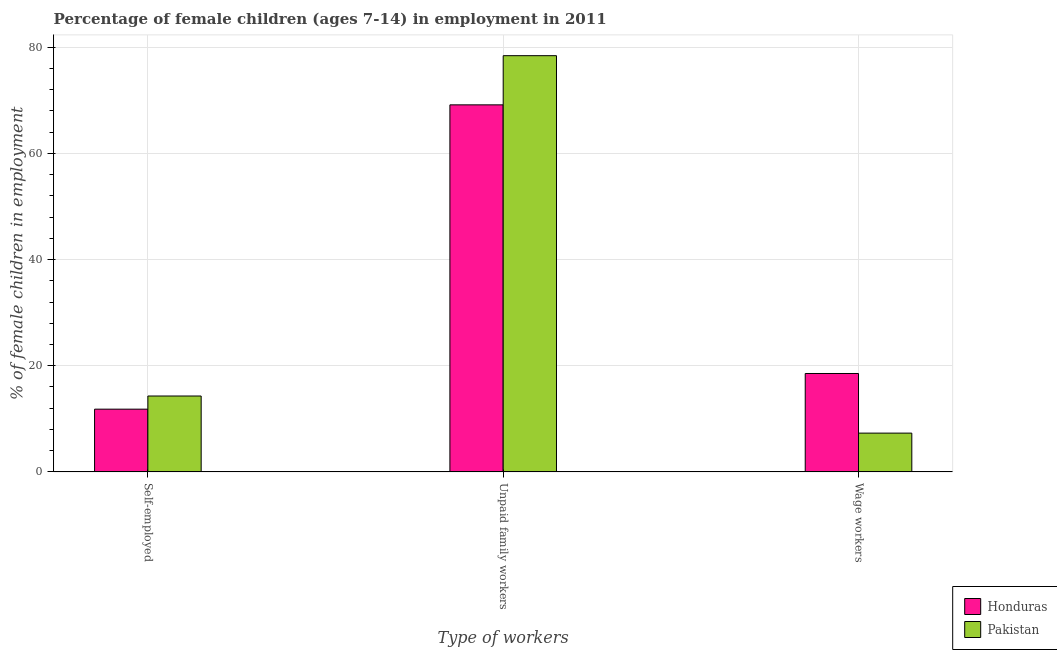How many bars are there on the 3rd tick from the right?
Offer a terse response. 2. What is the label of the 3rd group of bars from the left?
Give a very brief answer. Wage workers. What is the percentage of self employed children in Honduras?
Give a very brief answer. 11.82. Across all countries, what is the minimum percentage of children employed as wage workers?
Offer a terse response. 7.31. In which country was the percentage of children employed as wage workers maximum?
Your answer should be very brief. Honduras. In which country was the percentage of children employed as wage workers minimum?
Provide a short and direct response. Pakistan. What is the total percentage of children employed as unpaid family workers in the graph?
Ensure brevity in your answer.  147.52. What is the difference between the percentage of children employed as unpaid family workers in Honduras and that in Pakistan?
Ensure brevity in your answer.  -9.26. What is the difference between the percentage of self employed children in Pakistan and the percentage of children employed as wage workers in Honduras?
Offer a very short reply. -4.24. What is the average percentage of children employed as unpaid family workers per country?
Keep it short and to the point. 73.76. What is the difference between the percentage of self employed children and percentage of children employed as unpaid family workers in Pakistan?
Keep it short and to the point. -64.09. What is the ratio of the percentage of self employed children in Pakistan to that in Honduras?
Offer a terse response. 1.21. Is the percentage of children employed as wage workers in Pakistan less than that in Honduras?
Your answer should be compact. Yes. Is the difference between the percentage of self employed children in Pakistan and Honduras greater than the difference between the percentage of children employed as wage workers in Pakistan and Honduras?
Your answer should be compact. Yes. What is the difference between the highest and the second highest percentage of children employed as unpaid family workers?
Your answer should be very brief. 9.26. What is the difference between the highest and the lowest percentage of self employed children?
Provide a short and direct response. 2.48. Is the sum of the percentage of self employed children in Honduras and Pakistan greater than the maximum percentage of children employed as wage workers across all countries?
Give a very brief answer. Yes. What does the 1st bar from the left in Wage workers represents?
Your answer should be very brief. Honduras. What does the 1st bar from the right in Unpaid family workers represents?
Provide a succinct answer. Pakistan. Is it the case that in every country, the sum of the percentage of self employed children and percentage of children employed as unpaid family workers is greater than the percentage of children employed as wage workers?
Give a very brief answer. Yes. Are the values on the major ticks of Y-axis written in scientific E-notation?
Ensure brevity in your answer.  No. Does the graph contain any zero values?
Provide a succinct answer. No. Does the graph contain grids?
Keep it short and to the point. Yes. How many legend labels are there?
Make the answer very short. 2. What is the title of the graph?
Keep it short and to the point. Percentage of female children (ages 7-14) in employment in 2011. Does "Least developed countries" appear as one of the legend labels in the graph?
Provide a short and direct response. No. What is the label or title of the X-axis?
Make the answer very short. Type of workers. What is the label or title of the Y-axis?
Offer a very short reply. % of female children in employment. What is the % of female children in employment in Honduras in Self-employed?
Make the answer very short. 11.82. What is the % of female children in employment in Pakistan in Self-employed?
Give a very brief answer. 14.3. What is the % of female children in employment in Honduras in Unpaid family workers?
Offer a terse response. 69.13. What is the % of female children in employment of Pakistan in Unpaid family workers?
Your answer should be very brief. 78.39. What is the % of female children in employment in Honduras in Wage workers?
Your answer should be compact. 18.54. What is the % of female children in employment in Pakistan in Wage workers?
Give a very brief answer. 7.31. Across all Type of workers, what is the maximum % of female children in employment of Honduras?
Keep it short and to the point. 69.13. Across all Type of workers, what is the maximum % of female children in employment in Pakistan?
Offer a terse response. 78.39. Across all Type of workers, what is the minimum % of female children in employment of Honduras?
Offer a terse response. 11.82. Across all Type of workers, what is the minimum % of female children in employment of Pakistan?
Ensure brevity in your answer.  7.31. What is the total % of female children in employment in Honduras in the graph?
Your response must be concise. 99.49. What is the difference between the % of female children in employment in Honduras in Self-employed and that in Unpaid family workers?
Your response must be concise. -57.31. What is the difference between the % of female children in employment of Pakistan in Self-employed and that in Unpaid family workers?
Offer a very short reply. -64.09. What is the difference between the % of female children in employment in Honduras in Self-employed and that in Wage workers?
Give a very brief answer. -6.72. What is the difference between the % of female children in employment in Pakistan in Self-employed and that in Wage workers?
Provide a succinct answer. 6.99. What is the difference between the % of female children in employment of Honduras in Unpaid family workers and that in Wage workers?
Your response must be concise. 50.59. What is the difference between the % of female children in employment of Pakistan in Unpaid family workers and that in Wage workers?
Keep it short and to the point. 71.08. What is the difference between the % of female children in employment of Honduras in Self-employed and the % of female children in employment of Pakistan in Unpaid family workers?
Ensure brevity in your answer.  -66.57. What is the difference between the % of female children in employment of Honduras in Self-employed and the % of female children in employment of Pakistan in Wage workers?
Offer a very short reply. 4.51. What is the difference between the % of female children in employment of Honduras in Unpaid family workers and the % of female children in employment of Pakistan in Wage workers?
Give a very brief answer. 61.82. What is the average % of female children in employment of Honduras per Type of workers?
Provide a succinct answer. 33.16. What is the average % of female children in employment of Pakistan per Type of workers?
Offer a terse response. 33.33. What is the difference between the % of female children in employment in Honduras and % of female children in employment in Pakistan in Self-employed?
Provide a short and direct response. -2.48. What is the difference between the % of female children in employment in Honduras and % of female children in employment in Pakistan in Unpaid family workers?
Make the answer very short. -9.26. What is the difference between the % of female children in employment of Honduras and % of female children in employment of Pakistan in Wage workers?
Keep it short and to the point. 11.23. What is the ratio of the % of female children in employment in Honduras in Self-employed to that in Unpaid family workers?
Make the answer very short. 0.17. What is the ratio of the % of female children in employment of Pakistan in Self-employed to that in Unpaid family workers?
Offer a very short reply. 0.18. What is the ratio of the % of female children in employment in Honduras in Self-employed to that in Wage workers?
Ensure brevity in your answer.  0.64. What is the ratio of the % of female children in employment in Pakistan in Self-employed to that in Wage workers?
Your answer should be very brief. 1.96. What is the ratio of the % of female children in employment of Honduras in Unpaid family workers to that in Wage workers?
Your answer should be compact. 3.73. What is the ratio of the % of female children in employment of Pakistan in Unpaid family workers to that in Wage workers?
Your answer should be very brief. 10.72. What is the difference between the highest and the second highest % of female children in employment in Honduras?
Ensure brevity in your answer.  50.59. What is the difference between the highest and the second highest % of female children in employment of Pakistan?
Ensure brevity in your answer.  64.09. What is the difference between the highest and the lowest % of female children in employment of Honduras?
Offer a terse response. 57.31. What is the difference between the highest and the lowest % of female children in employment in Pakistan?
Give a very brief answer. 71.08. 